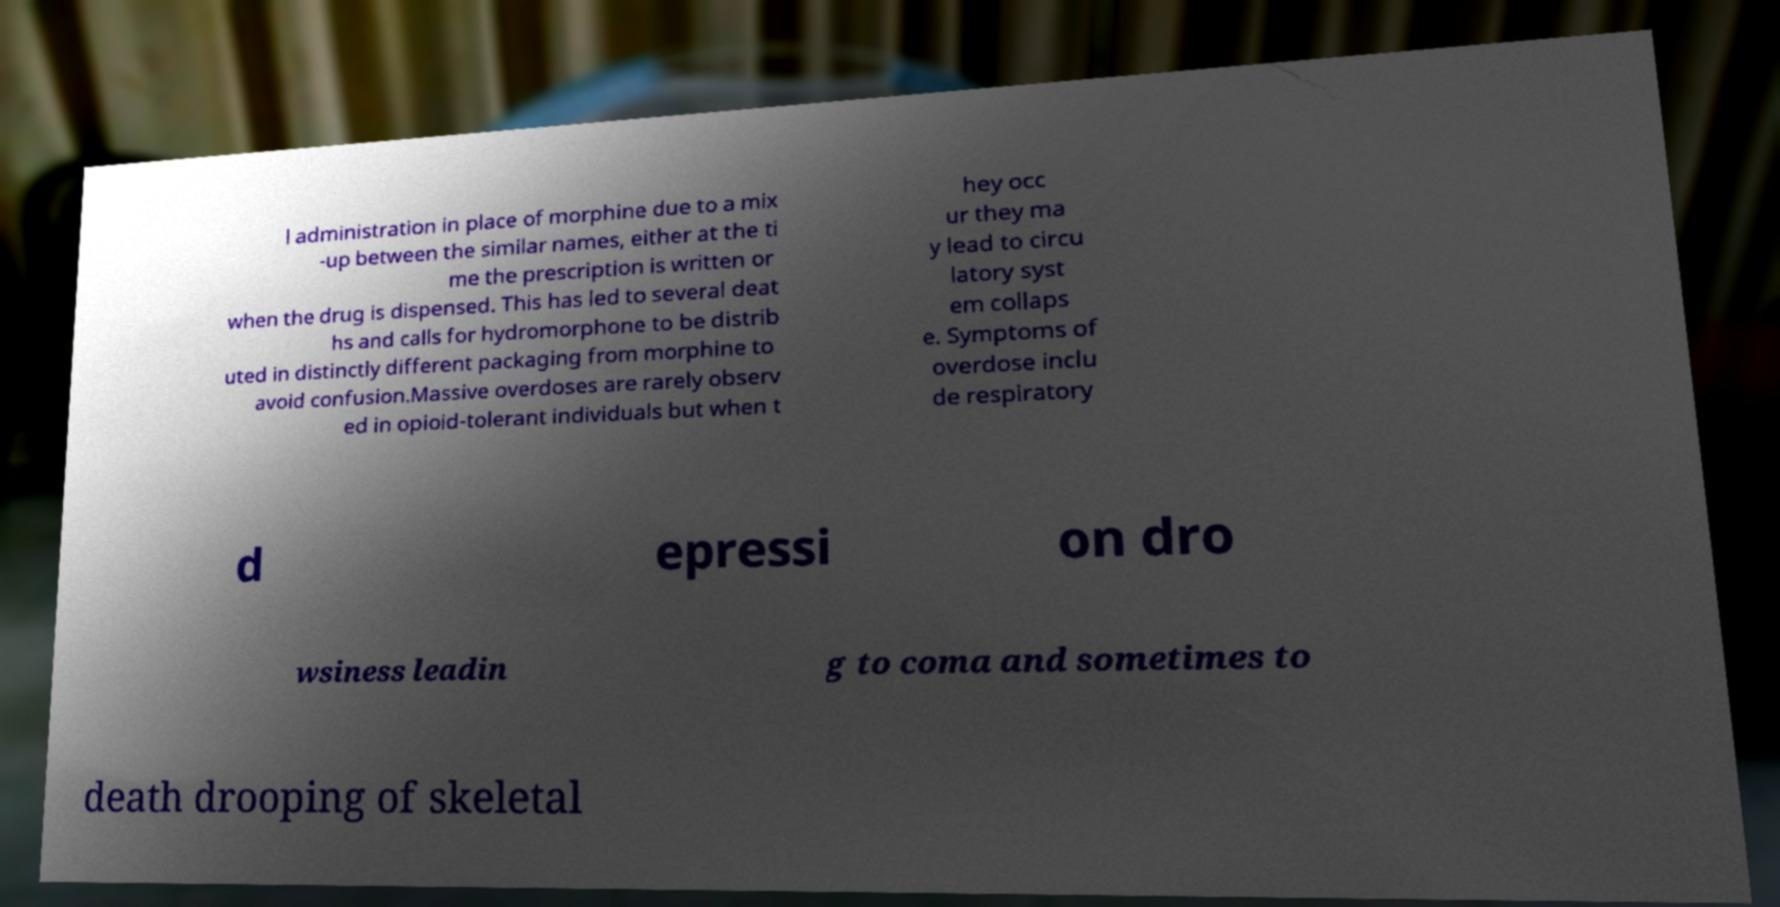Could you extract and type out the text from this image? l administration in place of morphine due to a mix -up between the similar names, either at the ti me the prescription is written or when the drug is dispensed. This has led to several deat hs and calls for hydromorphone to be distrib uted in distinctly different packaging from morphine to avoid confusion.Massive overdoses are rarely observ ed in opioid-tolerant individuals but when t hey occ ur they ma y lead to circu latory syst em collaps e. Symptoms of overdose inclu de respiratory d epressi on dro wsiness leadin g to coma and sometimes to death drooping of skeletal 